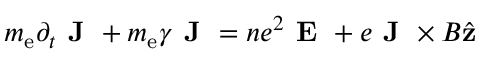<formula> <loc_0><loc_0><loc_500><loc_500>m _ { e } \partial _ { t } J + m _ { e } \gamma J = n e ^ { 2 } E + e J \times B \hat { z }</formula> 